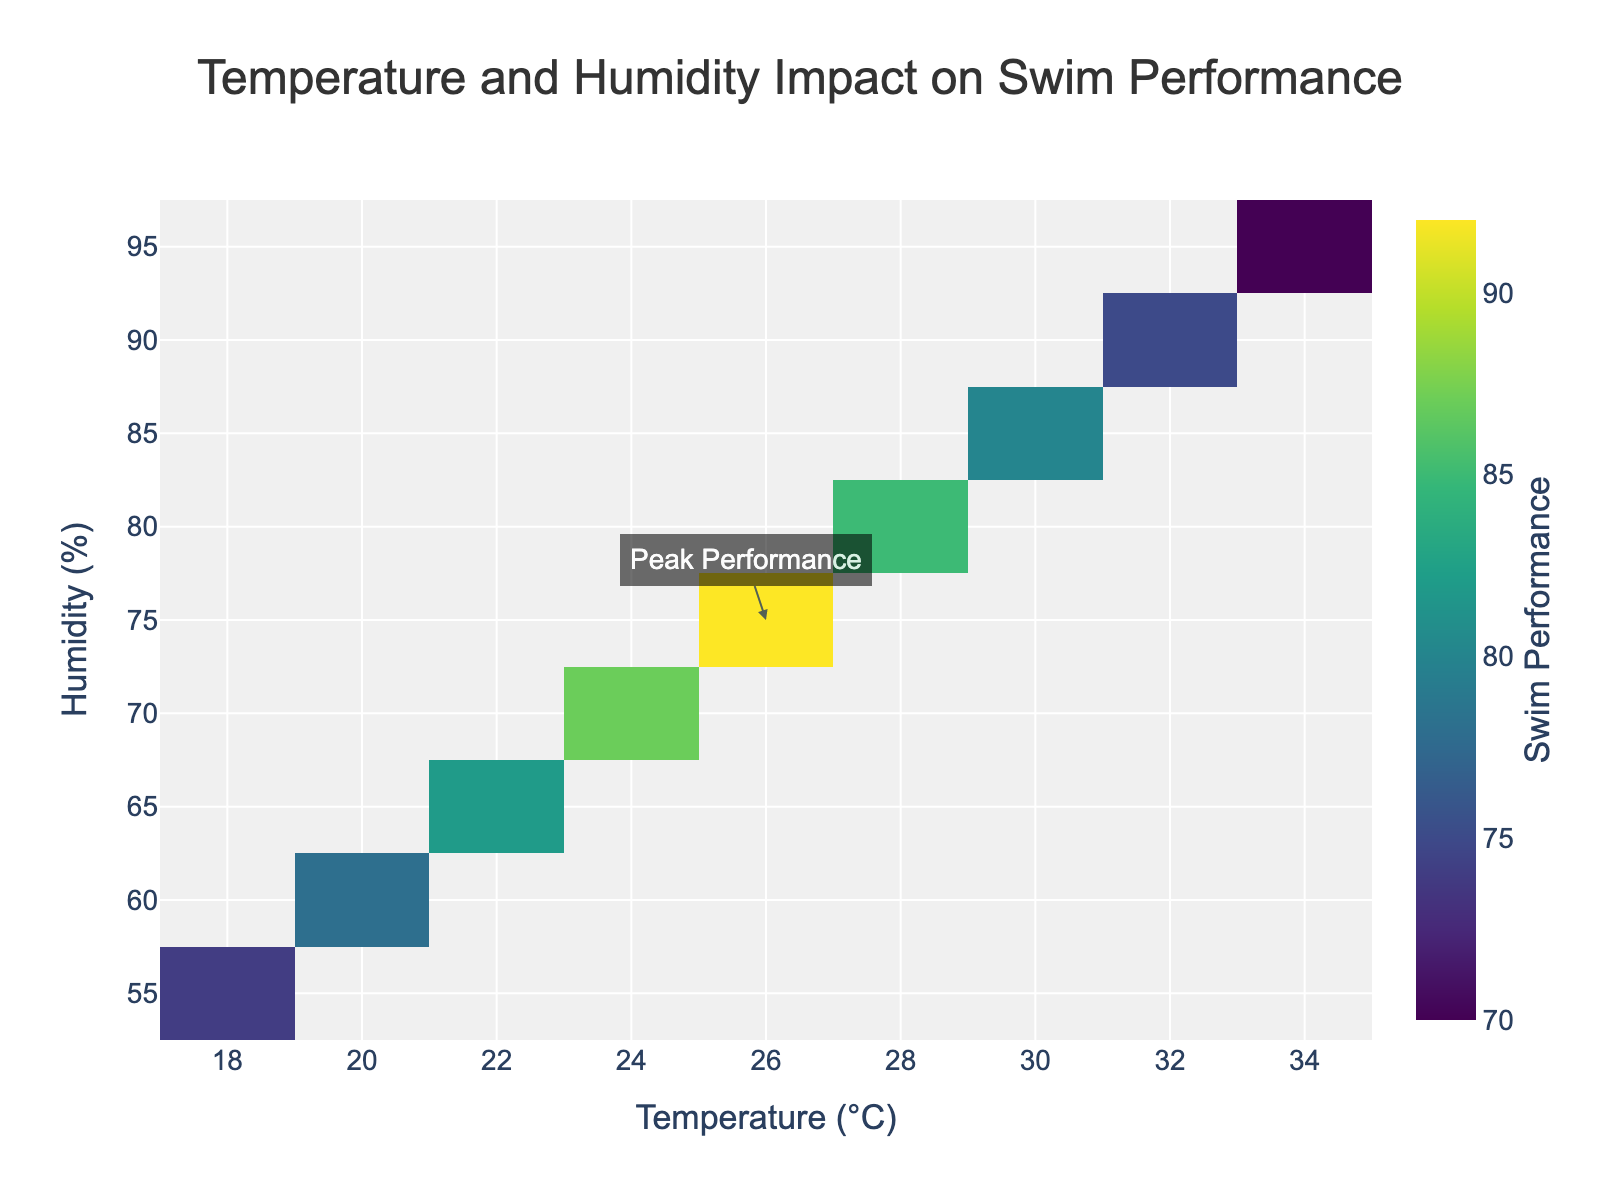What is the title of the figure? The title is located at the top of the figure and reads, "Temperature and Humidity Impact on Swim Performance."
Answer: Temperature and Humidity Impact on Swim Performance What does the colorbar represent? The colorbar, indicated on the right side of the heatmap, shows the swim performance levels. The range of colors from dark to bright represents different performance intensities, with the title "Swim Performance."
Answer: Swim Performance At what temperature and humidity is the peak performance observed? The annotation on the heatmap points to the temperature and humidity settings where the peak performance is recorded. The arrow points to 26°C and 75% humidity.
Answer: 26°C and 75% How does the swim performance change as temperature increases from 18°C to 34°C at a humidity level of 55%? By examining the heatmap row corresponding to 55% humidity and following it horizontally from left to right, performance initially increases from 74 to 92 at around 26°C, then drops as temperature continues to rise, ending at 70 at 34°C.
Answer: Increases then decreases Which temperature-humidity condition results in the lowest swim performance? The least intense color indicates the lowest performance. The heatmap shows that at 34°C and 95% humidity, the performance is the lowest at 70.
Answer: 34°C and 95% Compare the swim performance at 24°C and 65% humidity to that at 30°C and 85% humidity. The performance at 24°C and 65% humidity is found by locating the respective cell in the heatmap, showing a performance of 87. For 30°C and 85% humidity, it shows a performance of 80. Comparing these values, performance is higher at 24°C and 65% humidity.
Answer: 87 at 24°C, 65%; 80 at 30°C, 85% What pattern do you observe in swim performance as the humidity level increases from 55% to 95% at a constant temperature of 24°C? By analyzing the vertical progression in the heatmap from 55% to 95% humidity at 24°C, swim performance gradually improves until it peaks at 70%, then drops off.
Answer: Increase, then decrease What trend is observed in swim performance at 20°C when humidity varies from 55% to 95%? Observing the heatmap at a constant temperature of 20°C and navigating vertically through humidity levels, swim performance rises from 78 to 92 as humidity reaches 75%, and then diminishes to 70 at 95% humidity.
Answer: Rise then fall Calculate the average swim performance across all temperature and humidity conditions. Determining the average involves summing all swim performance values (74 + 78 + 82 + 87 + 92 + 85 + 80 + 75 + 70) = 723 and dividing by the total number of conditions (9). So, the average performance is 723/9 = 80.33.
Answer: 80.33 